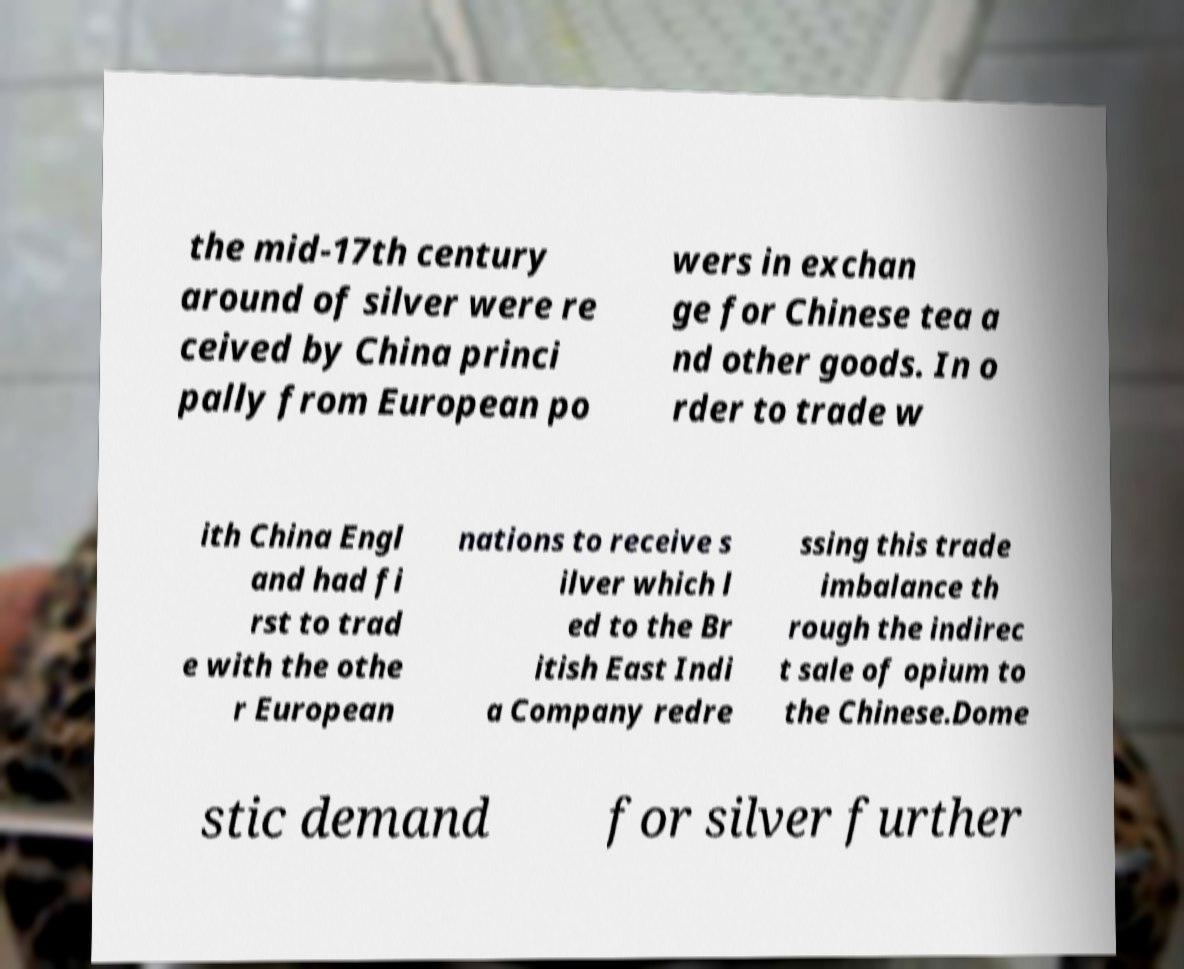Could you assist in decoding the text presented in this image and type it out clearly? the mid-17th century around of silver were re ceived by China princi pally from European po wers in exchan ge for Chinese tea a nd other goods. In o rder to trade w ith China Engl and had fi rst to trad e with the othe r European nations to receive s ilver which l ed to the Br itish East Indi a Company redre ssing this trade imbalance th rough the indirec t sale of opium to the Chinese.Dome stic demand for silver further 